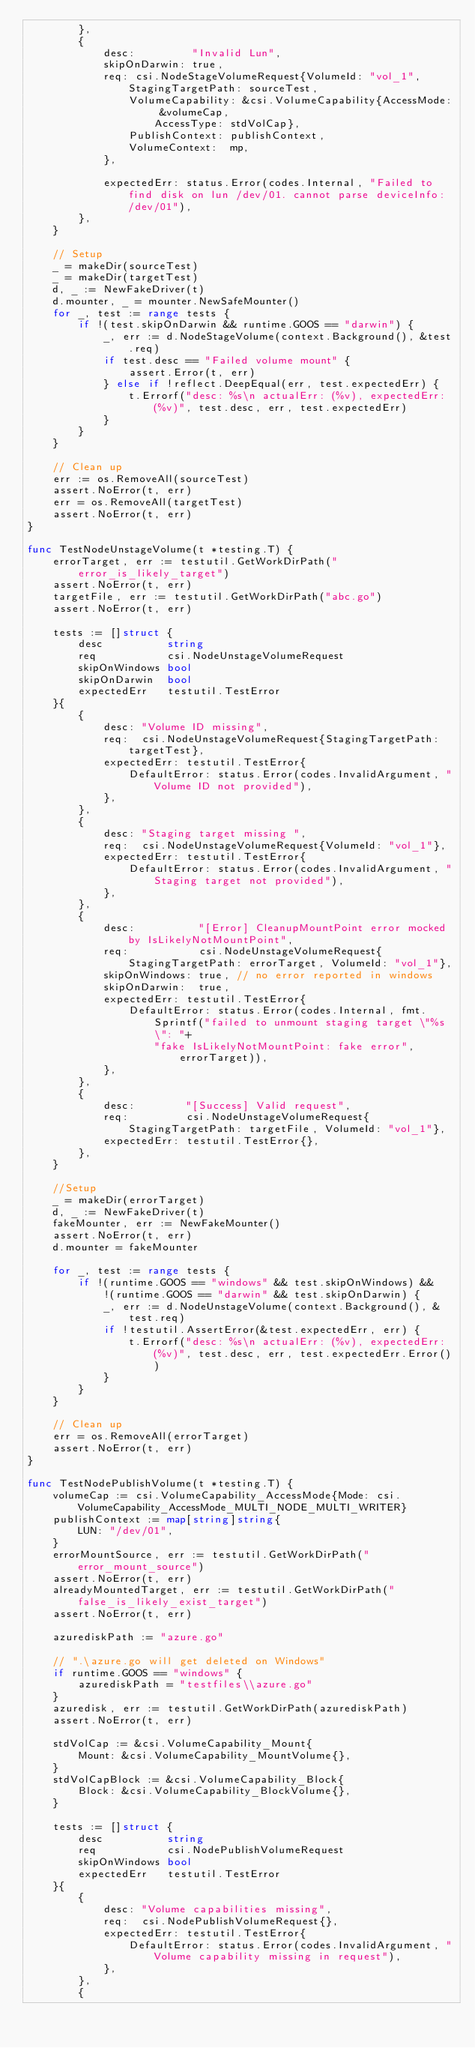<code> <loc_0><loc_0><loc_500><loc_500><_Go_>		},
		{
			desc:         "Invalid Lun",
			skipOnDarwin: true,
			req: csi.NodeStageVolumeRequest{VolumeId: "vol_1", StagingTargetPath: sourceTest,
				VolumeCapability: &csi.VolumeCapability{AccessMode: &volumeCap,
					AccessType: stdVolCap},
				PublishContext: publishContext,
				VolumeContext:  mp,
			},

			expectedErr: status.Error(codes.Internal, "Failed to find disk on lun /dev/01. cannot parse deviceInfo: /dev/01"),
		},
	}

	// Setup
	_ = makeDir(sourceTest)
	_ = makeDir(targetTest)
	d, _ := NewFakeDriver(t)
	d.mounter, _ = mounter.NewSafeMounter()
	for _, test := range tests {
		if !(test.skipOnDarwin && runtime.GOOS == "darwin") {
			_, err := d.NodeStageVolume(context.Background(), &test.req)
			if test.desc == "Failed volume mount" {
				assert.Error(t, err)
			} else if !reflect.DeepEqual(err, test.expectedErr) {
				t.Errorf("desc: %s\n actualErr: (%v), expectedErr: (%v)", test.desc, err, test.expectedErr)
			}
		}
	}

	// Clean up
	err := os.RemoveAll(sourceTest)
	assert.NoError(t, err)
	err = os.RemoveAll(targetTest)
	assert.NoError(t, err)
}

func TestNodeUnstageVolume(t *testing.T) {
	errorTarget, err := testutil.GetWorkDirPath("error_is_likely_target")
	assert.NoError(t, err)
	targetFile, err := testutil.GetWorkDirPath("abc.go")
	assert.NoError(t, err)

	tests := []struct {
		desc          string
		req           csi.NodeUnstageVolumeRequest
		skipOnWindows bool
		skipOnDarwin  bool
		expectedErr   testutil.TestError
	}{
		{
			desc: "Volume ID missing",
			req:  csi.NodeUnstageVolumeRequest{StagingTargetPath: targetTest},
			expectedErr: testutil.TestError{
				DefaultError: status.Error(codes.InvalidArgument, "Volume ID not provided"),
			},
		},
		{
			desc: "Staging target missing ",
			req:  csi.NodeUnstageVolumeRequest{VolumeId: "vol_1"},
			expectedErr: testutil.TestError{
				DefaultError: status.Error(codes.InvalidArgument, "Staging target not provided"),
			},
		},
		{
			desc:          "[Error] CleanupMountPoint error mocked by IsLikelyNotMountPoint",
			req:           csi.NodeUnstageVolumeRequest{StagingTargetPath: errorTarget, VolumeId: "vol_1"},
			skipOnWindows: true, // no error reported in windows
			skipOnDarwin:  true,
			expectedErr: testutil.TestError{
				DefaultError: status.Error(codes.Internal, fmt.Sprintf("failed to unmount staging target \"%s\": "+
					"fake IsLikelyNotMountPoint: fake error", errorTarget)),
			},
		},
		{
			desc:        "[Success] Valid request",
			req:         csi.NodeUnstageVolumeRequest{StagingTargetPath: targetFile, VolumeId: "vol_1"},
			expectedErr: testutil.TestError{},
		},
	}

	//Setup
	_ = makeDir(errorTarget)
	d, _ := NewFakeDriver(t)
	fakeMounter, err := NewFakeMounter()
	assert.NoError(t, err)
	d.mounter = fakeMounter

	for _, test := range tests {
		if !(runtime.GOOS == "windows" && test.skipOnWindows) &&
			!(runtime.GOOS == "darwin" && test.skipOnDarwin) {
			_, err := d.NodeUnstageVolume(context.Background(), &test.req)
			if !testutil.AssertError(&test.expectedErr, err) {
				t.Errorf("desc: %s\n actualErr: (%v), expectedErr: (%v)", test.desc, err, test.expectedErr.Error())
			}
		}
	}

	// Clean up
	err = os.RemoveAll(errorTarget)
	assert.NoError(t, err)
}

func TestNodePublishVolume(t *testing.T) {
	volumeCap := csi.VolumeCapability_AccessMode{Mode: csi.VolumeCapability_AccessMode_MULTI_NODE_MULTI_WRITER}
	publishContext := map[string]string{
		LUN: "/dev/01",
	}
	errorMountSource, err := testutil.GetWorkDirPath("error_mount_source")
	assert.NoError(t, err)
	alreadyMountedTarget, err := testutil.GetWorkDirPath("false_is_likely_exist_target")
	assert.NoError(t, err)

	azurediskPath := "azure.go"

	// ".\azure.go will get deleted on Windows"
	if runtime.GOOS == "windows" {
		azurediskPath = "testfiles\\azure.go"
	}
	azuredisk, err := testutil.GetWorkDirPath(azurediskPath)
	assert.NoError(t, err)

	stdVolCap := &csi.VolumeCapability_Mount{
		Mount: &csi.VolumeCapability_MountVolume{},
	}
	stdVolCapBlock := &csi.VolumeCapability_Block{
		Block: &csi.VolumeCapability_BlockVolume{},
	}

	tests := []struct {
		desc          string
		req           csi.NodePublishVolumeRequest
		skipOnWindows bool
		expectedErr   testutil.TestError
	}{
		{
			desc: "Volume capabilities missing",
			req:  csi.NodePublishVolumeRequest{},
			expectedErr: testutil.TestError{
				DefaultError: status.Error(codes.InvalidArgument, "Volume capability missing in request"),
			},
		},
		{</code> 